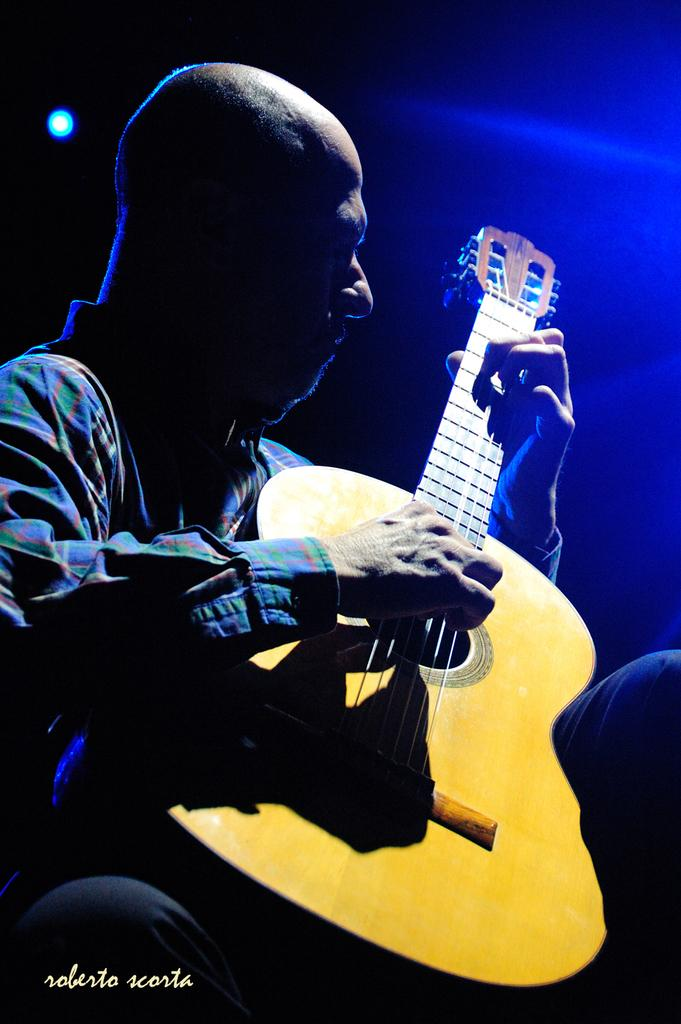Who is the main subject in the image? There is a man in the image. What is the man doing in the image? The man is playing a yellow guitar. What can be seen in the background of the image? There is a light in the background of the image. Can you describe the lighting on the left side of the image? There is a blue light on the left side of the image. How many dogs are present in the image? There are no dogs present in the image. What nation is the man representing in the image? The image does not provide any information about the man representing a specific nation. 